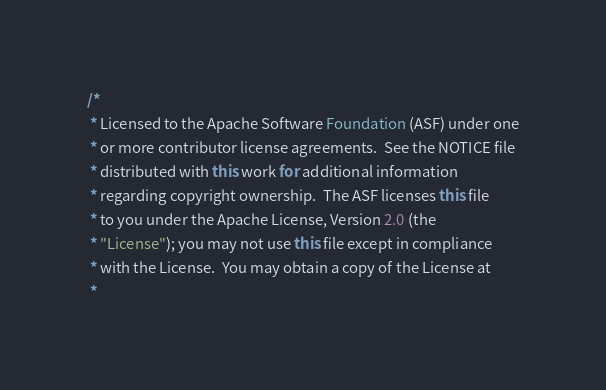Convert code to text. <code><loc_0><loc_0><loc_500><loc_500><_Java_>/*
 * Licensed to the Apache Software Foundation (ASF) under one
 * or more contributor license agreements.  See the NOTICE file
 * distributed with this work for additional information
 * regarding copyright ownership.  The ASF licenses this file
 * to you under the Apache License, Version 2.0 (the
 * "License"); you may not use this file except in compliance
 * with the License.  You may obtain a copy of the License at
 *</code> 